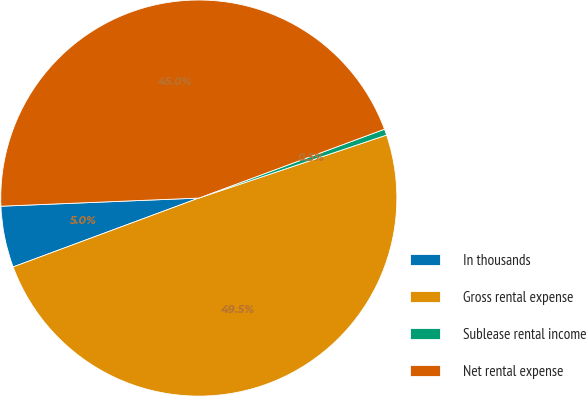Convert chart. <chart><loc_0><loc_0><loc_500><loc_500><pie_chart><fcel>In thousands<fcel>Gross rental expense<fcel>Sublease rental income<fcel>Net rental expense<nl><fcel>5.0%<fcel>49.5%<fcel>0.5%<fcel>45.0%<nl></chart> 